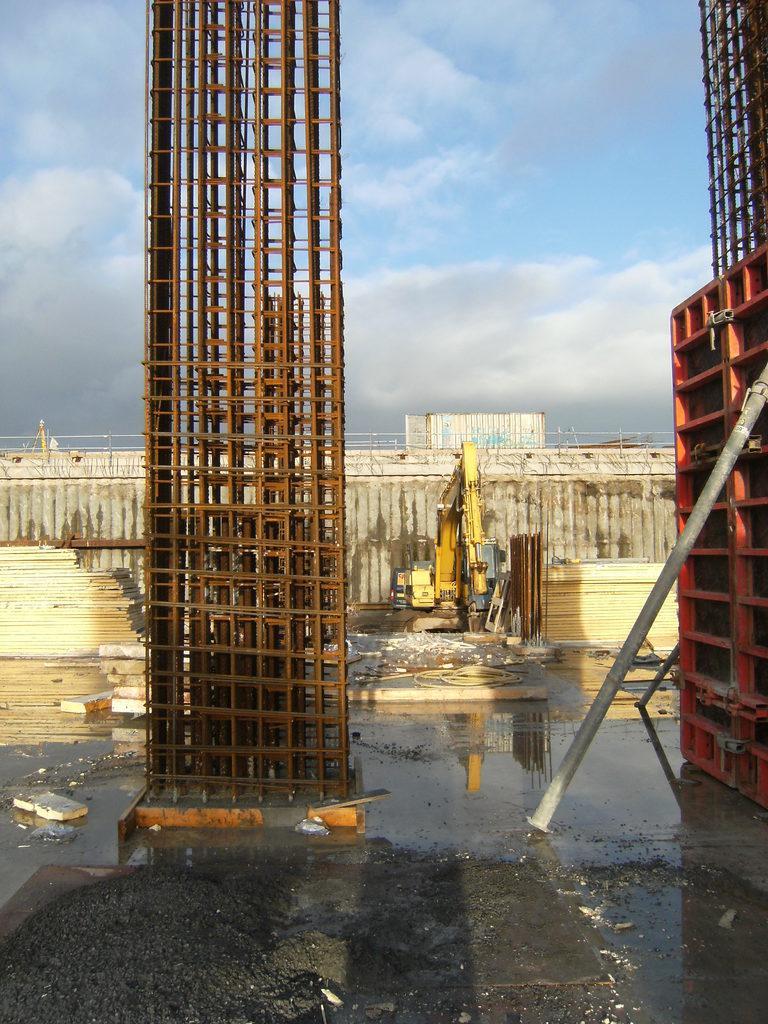Describe this image in one or two sentences. This picture is completely a construction area. These are the pillars. At the top we can see sky with clouds. Here on the floor we can see water. On the background we can see excavator. 